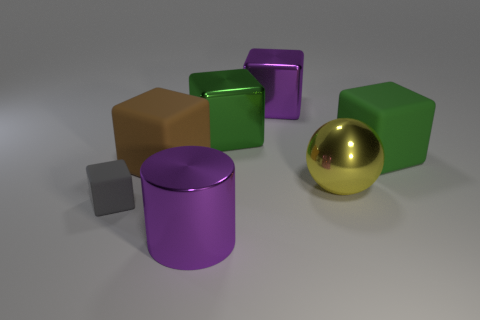Add 1 green blocks. How many objects exist? 8 Subtract all large green cubes. How many cubes are left? 3 Subtract all brown cubes. How many cubes are left? 4 Subtract all cubes. How many objects are left? 2 Subtract 2 cubes. How many cubes are left? 3 Subtract 0 red balls. How many objects are left? 7 Subtract all purple cubes. Subtract all purple cylinders. How many cubes are left? 4 Subtract all cyan cylinders. How many yellow blocks are left? 0 Subtract all big spheres. Subtract all small gray rubber cylinders. How many objects are left? 6 Add 5 small objects. How many small objects are left? 6 